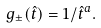<formula> <loc_0><loc_0><loc_500><loc_500>g _ { \pm } ( \hat { t } ) = 1 / \hat { t } ^ { a } .</formula> 